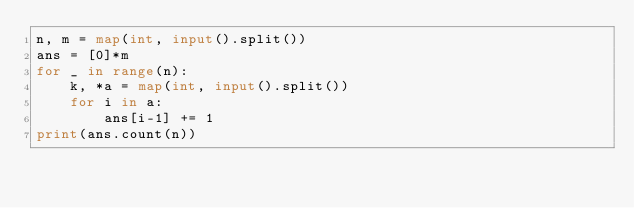Convert code to text. <code><loc_0><loc_0><loc_500><loc_500><_Python_>n, m = map(int, input().split())
ans = [0]*m
for _ in range(n):
    k, *a = map(int, input().split())
    for i in a:
        ans[i-1] += 1
print(ans.count(n))</code> 